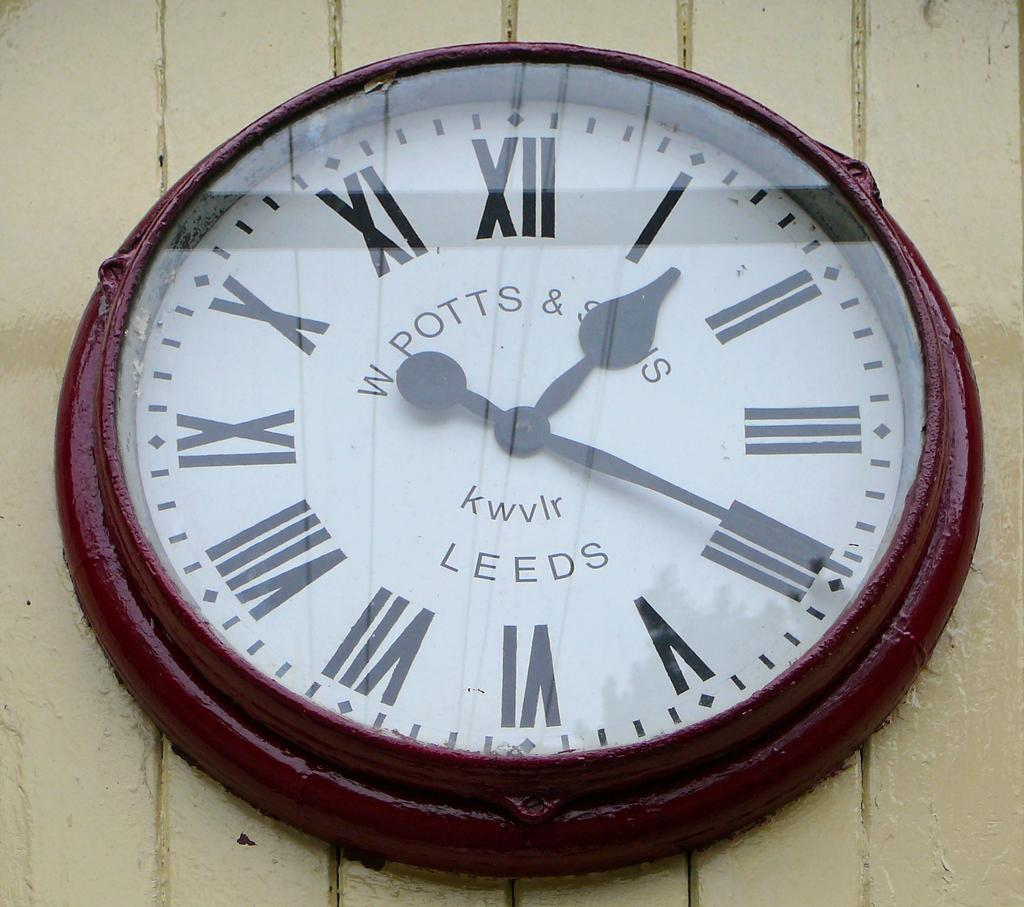<image>
Share a concise interpretation of the image provided. A round antique clock made by W Potts and Sons 